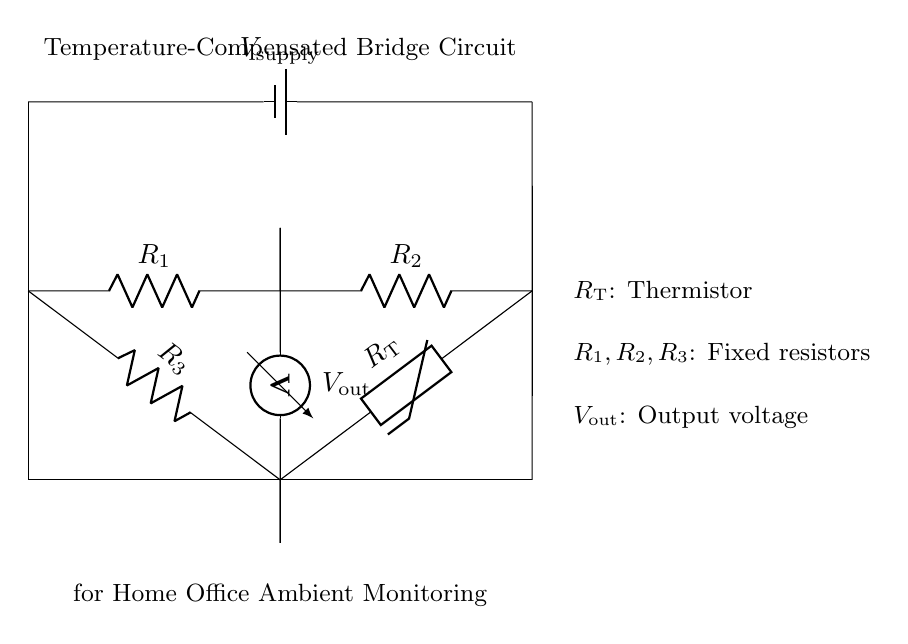What does the circuit primarily monitor? The circuit primarily monitors temperature, indicated by the presence of a thermistor in the bridge.
Answer: Temperature What is the role of the thermistor in the circuit? The thermistor, labeled as R_T in the circuit, changes its resistance based on temperature, affecting the output voltage of the bridge circuit.
Answer: Temperature measurement How many fixed resistors are present in the circuit? There are three fixed resistors labeled as R_1, R_2, and R_3 in the circuit, as indicated in the diagram.
Answer: Three What is the output component of the bridge circuit? The output component of the bridge circuit is the voltmeter, which measures the output voltage (V_out) generated by the imbalance in the bridge due to temperature changes.
Answer: Voltmeter What type of circuit is this? This is a temperature-compensated bridge circuit, specifically designed for monitoring ambient conditions, as indicated in the title of the diagram.
Answer: Bridge circuit What effect does changing temperature have on the output voltage? Changing temperature affects the resistance of the thermistor, thereby causing a variation in output voltage (V_out) according to the bridge balance condition.
Answer: Variation in output voltage What is the supply voltage labeled as? The supply voltage is labeled as V_supply in the circuit, serving as the voltage source for the entire bridge configuration.
Answer: V_supply 